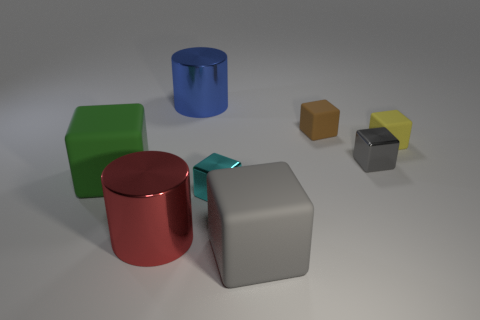Subtract all yellow blocks. How many blocks are left? 5 Subtract all green cylinders. How many gray blocks are left? 2 Subtract all cyan blocks. How many blocks are left? 5 Subtract 1 cylinders. How many cylinders are left? 1 Add 1 yellow objects. How many objects exist? 9 Subtract all cubes. How many objects are left? 2 Subtract all small cyan metallic cylinders. Subtract all cylinders. How many objects are left? 6 Add 4 green objects. How many green objects are left? 5 Add 4 gray shiny objects. How many gray shiny objects exist? 5 Subtract 1 yellow cubes. How many objects are left? 7 